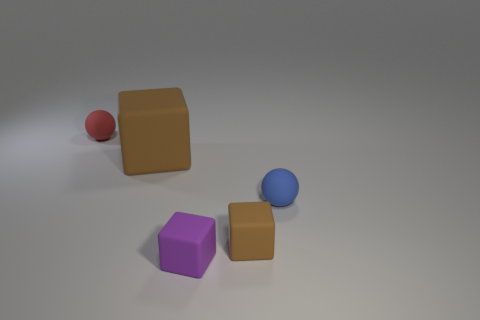Is the number of big brown blocks in front of the tiny purple rubber block greater than the number of big red cylinders?
Offer a terse response. No. There is another block that is the same color as the big rubber block; what size is it?
Your response must be concise. Small. Is there another big rubber object of the same shape as the red thing?
Provide a short and direct response. No. What number of things are either gray shiny cubes or blue balls?
Make the answer very short. 1. How many tiny things are to the right of the small matte sphere to the left of the small rubber block that is on the left side of the small brown cube?
Provide a short and direct response. 3. What material is the big brown thing that is the same shape as the purple matte object?
Give a very brief answer. Rubber. The small object that is behind the small brown thing and to the left of the blue rubber ball is made of what material?
Offer a terse response. Rubber. Is the number of large brown matte blocks to the left of the red object less than the number of tiny brown blocks that are behind the large matte cube?
Provide a succinct answer. No. How many other objects are the same size as the red thing?
Offer a terse response. 3. What is the shape of the tiny thing that is left of the purple cube in front of the ball that is behind the small blue matte object?
Your answer should be compact. Sphere. 